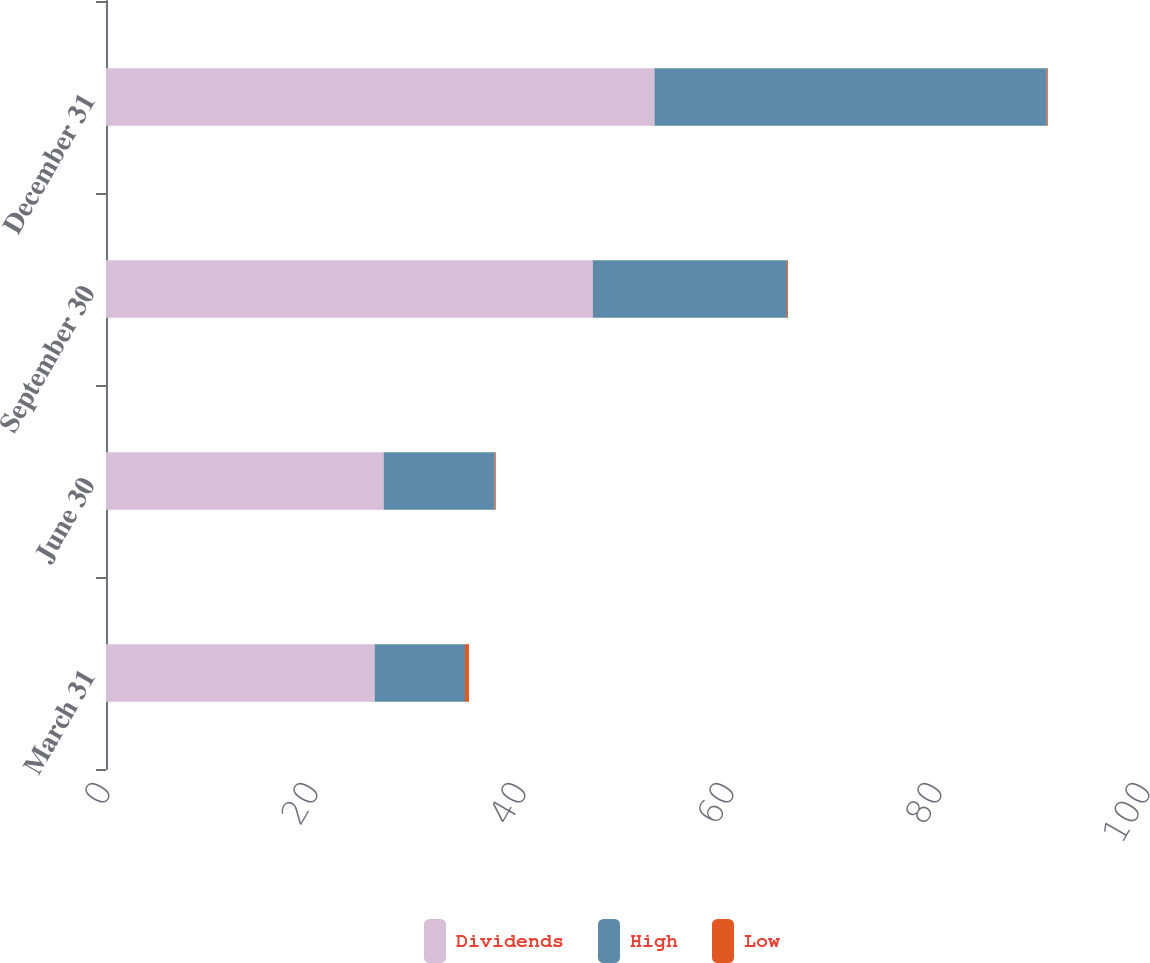Convert chart to OTSL. <chart><loc_0><loc_0><loc_500><loc_500><stacked_bar_chart><ecel><fcel>March 31<fcel>June 30<fcel>September 30<fcel>December 31<nl><fcel>Dividends<fcel>25.83<fcel>26.7<fcel>46.81<fcel>52.74<nl><fcel>High<fcel>8.69<fcel>10.68<fcel>18.66<fcel>37.72<nl><fcel>Low<fcel>0.38<fcel>0.1<fcel>0.1<fcel>0.1<nl></chart> 